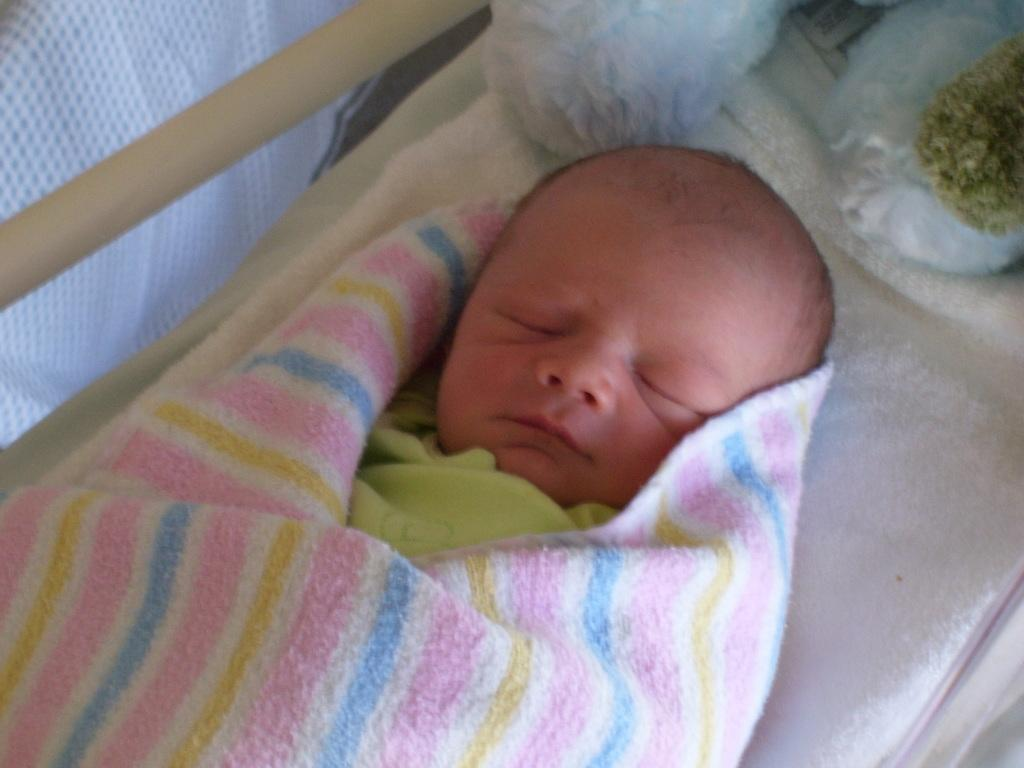What is the main subject of the image? There is a baby in the image. What is the baby doing in the image? The baby is sleeping on the bed. Can you describe the objects at the top of the image? There are two objects at the top of the image, but their specific details are not mentioned in the facts. What is covering the baby in the image? There is a blanket around the baby. What type of toothbrush is the baby using in the image? There is no toothbrush present in the image. What role does the marble play in the baby's sleep in the image? There is no marble present in the image. 